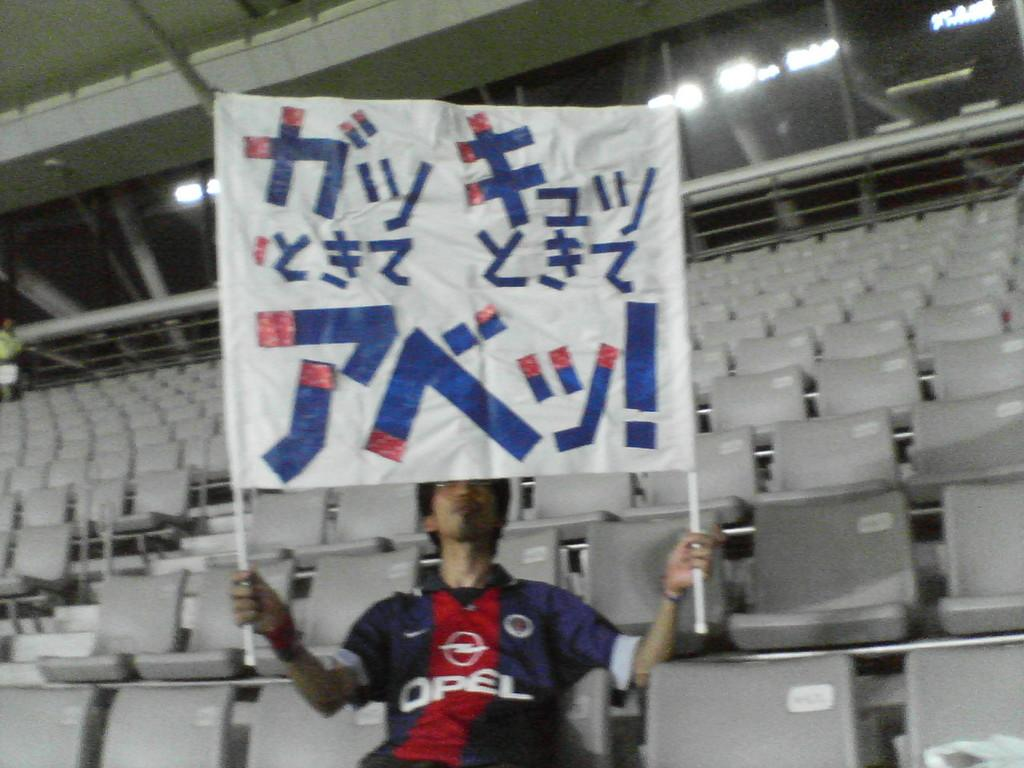<image>
Create a compact narrative representing the image presented. A man in an opel shirt holds up a red, white, and blue sign. 